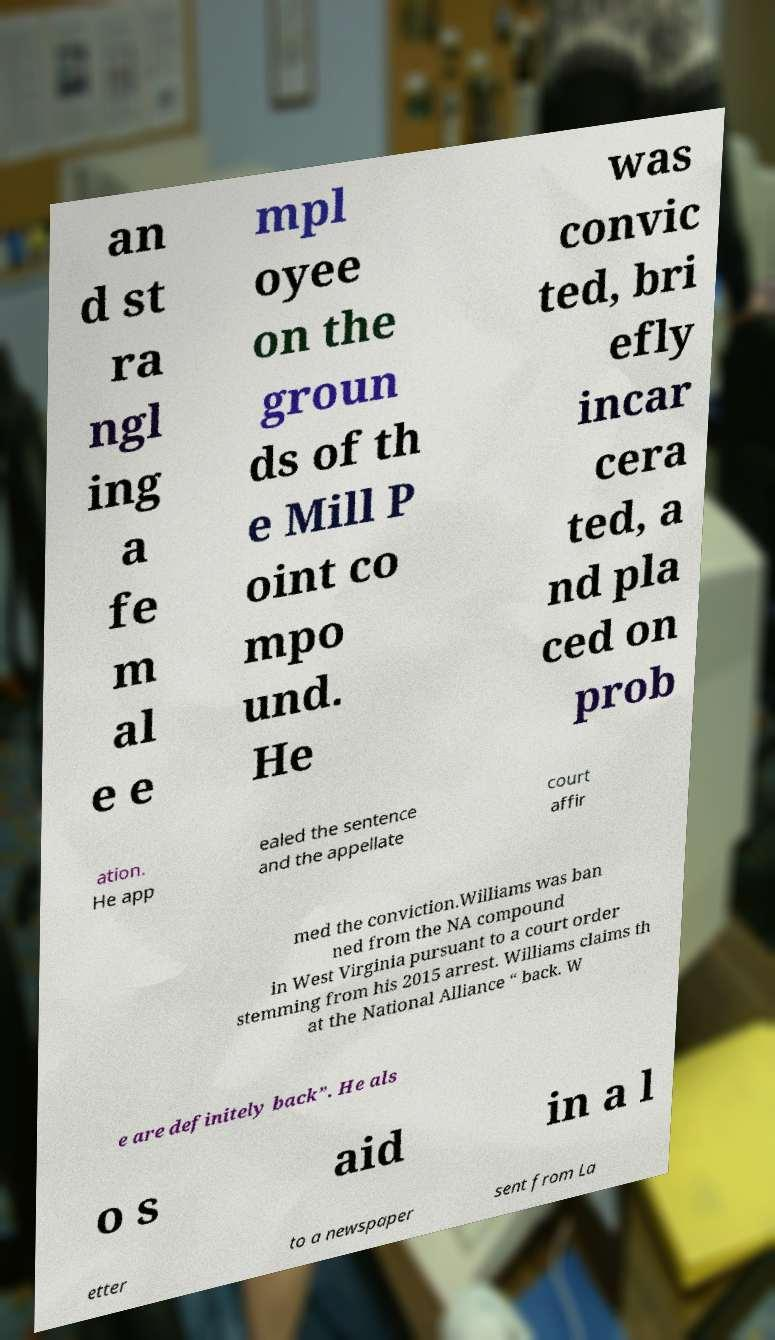Please read and relay the text visible in this image. What does it say? an d st ra ngl ing a fe m al e e mpl oyee on the groun ds of th e Mill P oint co mpo und. He was convic ted, bri efly incar cera ted, a nd pla ced on prob ation. He app ealed the sentence and the appellate court affir med the conviction.Williams was ban ned from the NA compound in West Virginia pursuant to a court order stemming from his 2015 arrest. Williams claims th at the National Alliance “ back. W e are definitely back”. He als o s aid in a l etter to a newspaper sent from La 